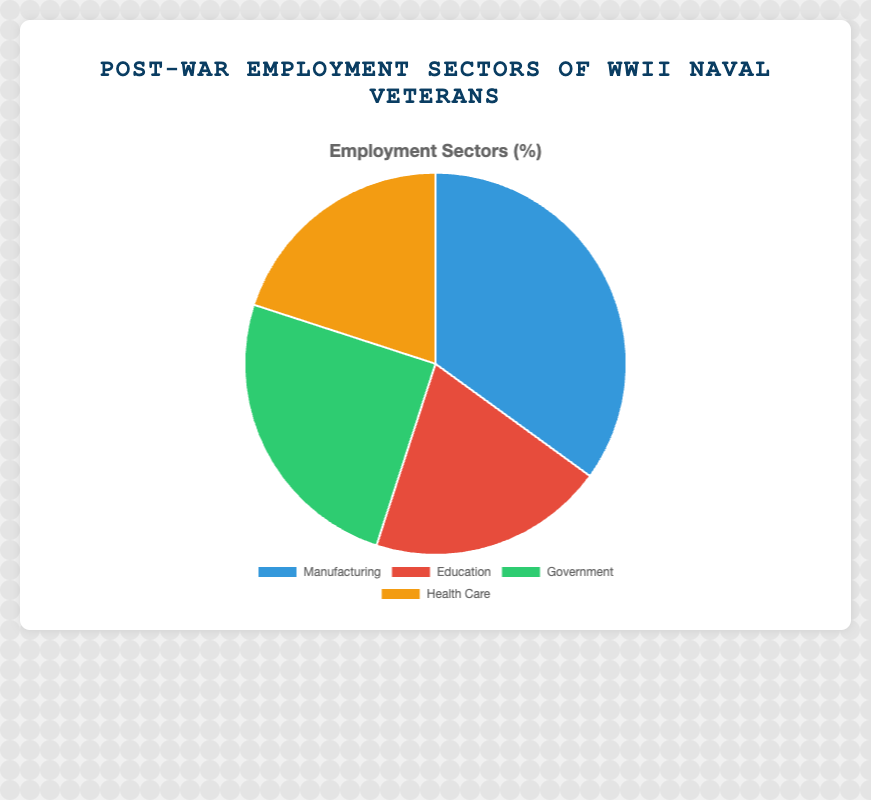What's the total percentage of veterans employed in Education and Health Care combined? The percentage of veterans in Education is 20%, and in Health Care, it is also 20%. The combined percentage is calculated by summing these two values: 20% + 20% = 40%
Answer: 40% Which employment sector has the highest percentage of WWII Naval Veterans? By examining the pie chart, we see that Manufacturing has the highest percentage at 35%.
Answer: Manufacturing How does the percentage of veterans in Government compare to those in Education? The percentage of veterans in Government is 25%, and in Education, it is 20%. So, the Government sector has 5% more veterans than Education.
Answer: Government has 5% more What is the difference in the percentage between the highest and the lowest employment sectors? The highest percentage is in Manufacturing at 35%, and the lowest percentages are in Education and Health Care both at 20%. The difference is 35% - 20% = 15%.
Answer: 15% If 10,000 veterans worked in Manufacturing, how many worked in Health Care? If 35% corresponds to 10,000 veterans in Manufacturing, 1% corresponds to about 285.7 veterans. Therefore, 20% in Health Care corresponds to 20 * 285.7 = 5,714 veterans.
Answer: Approximately 5,714 veterans Which sectors have the same percentage of employment? Both Education and Health Care have the same employment percentage of 20%.
Answer: Education and Health Care What is the average percentage of veterans across all sectors? To find the average percentage, sum all sector percentages (35% + 20% + 25% + 20% = 100%) and divide by the number of sectors (4). The average is 100% / 4 = 25%.
Answer: 25% How does the combined percentage of Government and Health Care compare to Manufacturing? Government has 25% and Health Care has 20%. Combined, they make 25% + 20% = 45%, which is greater than Manufacturing's 35% by 10%.
Answer: Combined sectors are 10% more What's the percentage gap between the smallest and second smallest sectors? The smallest sectors are Education and Health Care at 20% each. The second smallest sector is Government at 25%. The percentage gap is 25% - 20% = 5%.
Answer: 5% 